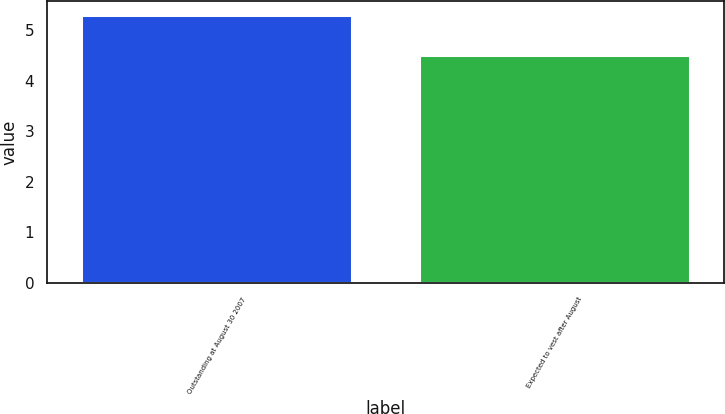Convert chart. <chart><loc_0><loc_0><loc_500><loc_500><bar_chart><fcel>Outstanding at August 30 2007<fcel>Expected to vest after August<nl><fcel>5.3<fcel>4.5<nl></chart> 